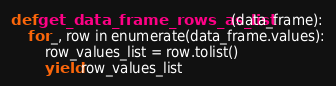<code> <loc_0><loc_0><loc_500><loc_500><_Python_>
def get_data_frame_rows_as_list(data_frame):
    for _, row in enumerate(data_frame.values):
        row_values_list = row.tolist()
        yield row_values_list
</code> 